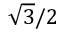<formula> <loc_0><loc_0><loc_500><loc_500>\sqrt { 3 } / 2</formula> 